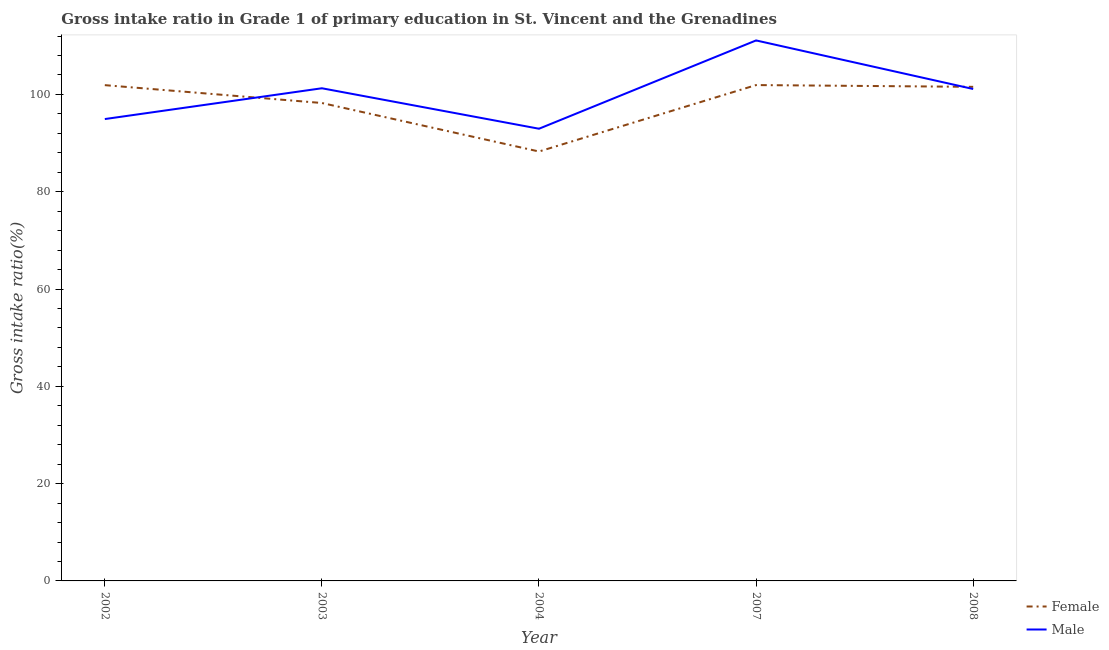What is the gross intake ratio(female) in 2007?
Make the answer very short. 101.93. Across all years, what is the maximum gross intake ratio(male)?
Keep it short and to the point. 111.1. Across all years, what is the minimum gross intake ratio(male)?
Keep it short and to the point. 92.95. In which year was the gross intake ratio(female) minimum?
Provide a short and direct response. 2004. What is the total gross intake ratio(male) in the graph?
Your answer should be compact. 501.37. What is the difference between the gross intake ratio(male) in 2003 and that in 2004?
Your response must be concise. 8.32. What is the difference between the gross intake ratio(female) in 2004 and the gross intake ratio(male) in 2003?
Provide a short and direct response. -13. What is the average gross intake ratio(female) per year?
Provide a short and direct response. 98.38. In the year 2004, what is the difference between the gross intake ratio(female) and gross intake ratio(male)?
Make the answer very short. -4.68. What is the ratio of the gross intake ratio(female) in 2007 to that in 2008?
Provide a succinct answer. 1. Is the gross intake ratio(female) in 2002 less than that in 2008?
Keep it short and to the point. No. Is the difference between the gross intake ratio(male) in 2007 and 2008 greater than the difference between the gross intake ratio(female) in 2007 and 2008?
Your answer should be very brief. Yes. What is the difference between the highest and the second highest gross intake ratio(female)?
Provide a succinct answer. 0.02. What is the difference between the highest and the lowest gross intake ratio(male)?
Your answer should be compact. 18.15. In how many years, is the gross intake ratio(male) greater than the average gross intake ratio(male) taken over all years?
Provide a short and direct response. 3. Is the sum of the gross intake ratio(female) in 2003 and 2004 greater than the maximum gross intake ratio(male) across all years?
Your response must be concise. Yes. Does the gross intake ratio(female) monotonically increase over the years?
Ensure brevity in your answer.  No. Does the graph contain grids?
Offer a very short reply. No. Where does the legend appear in the graph?
Give a very brief answer. Bottom right. How are the legend labels stacked?
Keep it short and to the point. Vertical. What is the title of the graph?
Give a very brief answer. Gross intake ratio in Grade 1 of primary education in St. Vincent and the Grenadines. Does "Age 65(female)" appear as one of the legend labels in the graph?
Offer a very short reply. No. What is the label or title of the X-axis?
Provide a succinct answer. Year. What is the label or title of the Y-axis?
Keep it short and to the point. Gross intake ratio(%). What is the Gross intake ratio(%) in Female in 2002?
Give a very brief answer. 101.91. What is the Gross intake ratio(%) of Male in 2002?
Provide a short and direct response. 94.94. What is the Gross intake ratio(%) of Female in 2003?
Offer a very short reply. 98.24. What is the Gross intake ratio(%) of Male in 2003?
Keep it short and to the point. 101.27. What is the Gross intake ratio(%) in Female in 2004?
Make the answer very short. 88.27. What is the Gross intake ratio(%) in Male in 2004?
Provide a short and direct response. 92.95. What is the Gross intake ratio(%) in Female in 2007?
Your answer should be compact. 101.93. What is the Gross intake ratio(%) in Male in 2007?
Offer a terse response. 111.1. What is the Gross intake ratio(%) in Female in 2008?
Make the answer very short. 101.56. What is the Gross intake ratio(%) in Male in 2008?
Keep it short and to the point. 101.12. Across all years, what is the maximum Gross intake ratio(%) of Female?
Your answer should be very brief. 101.93. Across all years, what is the maximum Gross intake ratio(%) in Male?
Offer a terse response. 111.1. Across all years, what is the minimum Gross intake ratio(%) in Female?
Give a very brief answer. 88.27. Across all years, what is the minimum Gross intake ratio(%) in Male?
Offer a terse response. 92.95. What is the total Gross intake ratio(%) of Female in the graph?
Offer a very short reply. 491.9. What is the total Gross intake ratio(%) in Male in the graph?
Provide a short and direct response. 501.38. What is the difference between the Gross intake ratio(%) of Female in 2002 and that in 2003?
Provide a succinct answer. 3.67. What is the difference between the Gross intake ratio(%) in Male in 2002 and that in 2003?
Your response must be concise. -6.33. What is the difference between the Gross intake ratio(%) of Female in 2002 and that in 2004?
Your answer should be compact. 13.64. What is the difference between the Gross intake ratio(%) in Male in 2002 and that in 2004?
Provide a succinct answer. 1.99. What is the difference between the Gross intake ratio(%) in Female in 2002 and that in 2007?
Provide a succinct answer. -0.02. What is the difference between the Gross intake ratio(%) of Male in 2002 and that in 2007?
Make the answer very short. -16.16. What is the difference between the Gross intake ratio(%) of Female in 2002 and that in 2008?
Your answer should be compact. 0.35. What is the difference between the Gross intake ratio(%) in Male in 2002 and that in 2008?
Make the answer very short. -6.18. What is the difference between the Gross intake ratio(%) of Female in 2003 and that in 2004?
Your answer should be compact. 9.97. What is the difference between the Gross intake ratio(%) of Male in 2003 and that in 2004?
Your answer should be compact. 8.32. What is the difference between the Gross intake ratio(%) of Female in 2003 and that in 2007?
Make the answer very short. -3.69. What is the difference between the Gross intake ratio(%) in Male in 2003 and that in 2007?
Give a very brief answer. -9.83. What is the difference between the Gross intake ratio(%) in Female in 2003 and that in 2008?
Keep it short and to the point. -3.32. What is the difference between the Gross intake ratio(%) of Male in 2003 and that in 2008?
Give a very brief answer. 0.15. What is the difference between the Gross intake ratio(%) in Female in 2004 and that in 2007?
Provide a succinct answer. -13.66. What is the difference between the Gross intake ratio(%) of Male in 2004 and that in 2007?
Keep it short and to the point. -18.15. What is the difference between the Gross intake ratio(%) of Female in 2004 and that in 2008?
Give a very brief answer. -13.29. What is the difference between the Gross intake ratio(%) in Male in 2004 and that in 2008?
Provide a succinct answer. -8.17. What is the difference between the Gross intake ratio(%) in Female in 2007 and that in 2008?
Ensure brevity in your answer.  0.36. What is the difference between the Gross intake ratio(%) of Male in 2007 and that in 2008?
Give a very brief answer. 9.98. What is the difference between the Gross intake ratio(%) of Female in 2002 and the Gross intake ratio(%) of Male in 2003?
Your answer should be compact. 0.64. What is the difference between the Gross intake ratio(%) in Female in 2002 and the Gross intake ratio(%) in Male in 2004?
Your response must be concise. 8.96. What is the difference between the Gross intake ratio(%) of Female in 2002 and the Gross intake ratio(%) of Male in 2007?
Keep it short and to the point. -9.19. What is the difference between the Gross intake ratio(%) of Female in 2002 and the Gross intake ratio(%) of Male in 2008?
Make the answer very short. 0.79. What is the difference between the Gross intake ratio(%) of Female in 2003 and the Gross intake ratio(%) of Male in 2004?
Offer a terse response. 5.29. What is the difference between the Gross intake ratio(%) in Female in 2003 and the Gross intake ratio(%) in Male in 2007?
Keep it short and to the point. -12.86. What is the difference between the Gross intake ratio(%) of Female in 2003 and the Gross intake ratio(%) of Male in 2008?
Provide a short and direct response. -2.88. What is the difference between the Gross intake ratio(%) in Female in 2004 and the Gross intake ratio(%) in Male in 2007?
Offer a very short reply. -22.83. What is the difference between the Gross intake ratio(%) in Female in 2004 and the Gross intake ratio(%) in Male in 2008?
Your response must be concise. -12.85. What is the difference between the Gross intake ratio(%) in Female in 2007 and the Gross intake ratio(%) in Male in 2008?
Your answer should be very brief. 0.81. What is the average Gross intake ratio(%) of Female per year?
Your answer should be compact. 98.38. What is the average Gross intake ratio(%) of Male per year?
Give a very brief answer. 100.28. In the year 2002, what is the difference between the Gross intake ratio(%) of Female and Gross intake ratio(%) of Male?
Offer a very short reply. 6.97. In the year 2003, what is the difference between the Gross intake ratio(%) in Female and Gross intake ratio(%) in Male?
Keep it short and to the point. -3.03. In the year 2004, what is the difference between the Gross intake ratio(%) of Female and Gross intake ratio(%) of Male?
Keep it short and to the point. -4.68. In the year 2007, what is the difference between the Gross intake ratio(%) in Female and Gross intake ratio(%) in Male?
Offer a very short reply. -9.18. In the year 2008, what is the difference between the Gross intake ratio(%) of Female and Gross intake ratio(%) of Male?
Keep it short and to the point. 0.44. What is the ratio of the Gross intake ratio(%) of Female in 2002 to that in 2003?
Provide a short and direct response. 1.04. What is the ratio of the Gross intake ratio(%) of Female in 2002 to that in 2004?
Your response must be concise. 1.15. What is the ratio of the Gross intake ratio(%) of Male in 2002 to that in 2004?
Offer a terse response. 1.02. What is the ratio of the Gross intake ratio(%) in Female in 2002 to that in 2007?
Give a very brief answer. 1. What is the ratio of the Gross intake ratio(%) of Male in 2002 to that in 2007?
Offer a terse response. 0.85. What is the ratio of the Gross intake ratio(%) in Male in 2002 to that in 2008?
Give a very brief answer. 0.94. What is the ratio of the Gross intake ratio(%) of Female in 2003 to that in 2004?
Provide a succinct answer. 1.11. What is the ratio of the Gross intake ratio(%) of Male in 2003 to that in 2004?
Your response must be concise. 1.09. What is the ratio of the Gross intake ratio(%) of Female in 2003 to that in 2007?
Ensure brevity in your answer.  0.96. What is the ratio of the Gross intake ratio(%) of Male in 2003 to that in 2007?
Give a very brief answer. 0.91. What is the ratio of the Gross intake ratio(%) in Female in 2003 to that in 2008?
Your answer should be compact. 0.97. What is the ratio of the Gross intake ratio(%) of Male in 2003 to that in 2008?
Make the answer very short. 1. What is the ratio of the Gross intake ratio(%) in Female in 2004 to that in 2007?
Your answer should be very brief. 0.87. What is the ratio of the Gross intake ratio(%) of Male in 2004 to that in 2007?
Your answer should be compact. 0.84. What is the ratio of the Gross intake ratio(%) of Female in 2004 to that in 2008?
Provide a succinct answer. 0.87. What is the ratio of the Gross intake ratio(%) in Male in 2004 to that in 2008?
Provide a short and direct response. 0.92. What is the ratio of the Gross intake ratio(%) of Female in 2007 to that in 2008?
Provide a short and direct response. 1. What is the ratio of the Gross intake ratio(%) of Male in 2007 to that in 2008?
Make the answer very short. 1.1. What is the difference between the highest and the second highest Gross intake ratio(%) in Female?
Your answer should be compact. 0.02. What is the difference between the highest and the second highest Gross intake ratio(%) of Male?
Your answer should be very brief. 9.83. What is the difference between the highest and the lowest Gross intake ratio(%) of Female?
Your answer should be compact. 13.66. What is the difference between the highest and the lowest Gross intake ratio(%) of Male?
Ensure brevity in your answer.  18.15. 